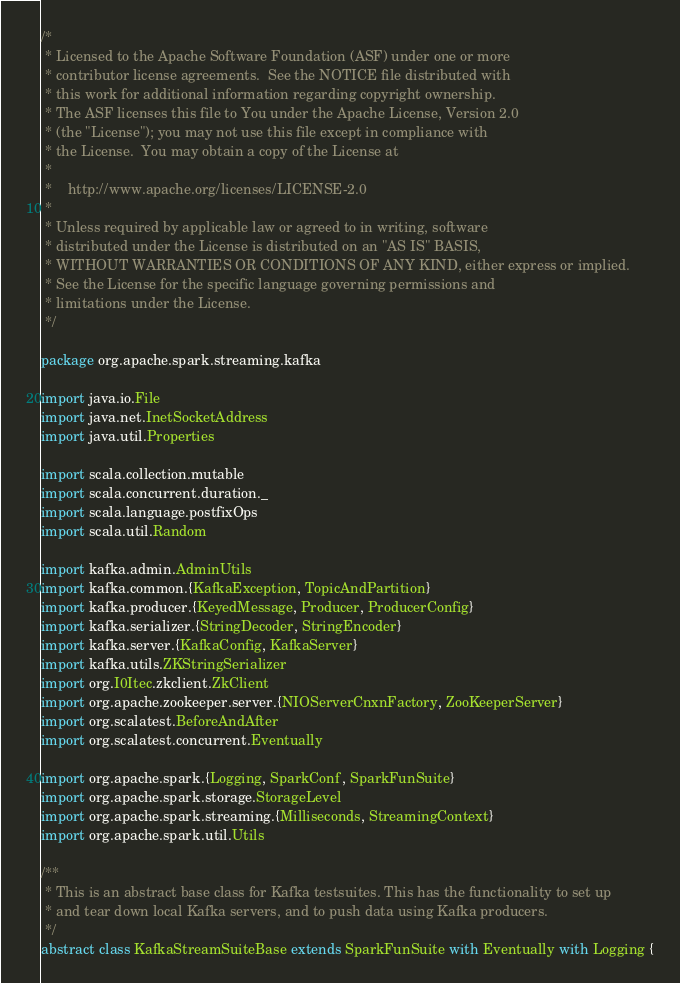<code> <loc_0><loc_0><loc_500><loc_500><_Scala_>/*
 * Licensed to the Apache Software Foundation (ASF) under one or more
 * contributor license agreements.  See the NOTICE file distributed with
 * this work for additional information regarding copyright ownership.
 * The ASF licenses this file to You under the Apache License, Version 2.0
 * (the "License"); you may not use this file except in compliance with
 * the License.  You may obtain a copy of the License at
 *
 *    http://www.apache.org/licenses/LICENSE-2.0
 *
 * Unless required by applicable law or agreed to in writing, software
 * distributed under the License is distributed on an "AS IS" BASIS,
 * WITHOUT WARRANTIES OR CONDITIONS OF ANY KIND, either express or implied.
 * See the License for the specific language governing permissions and
 * limitations under the License.
 */

package org.apache.spark.streaming.kafka

import java.io.File
import java.net.InetSocketAddress
import java.util.Properties

import scala.collection.mutable
import scala.concurrent.duration._
import scala.language.postfixOps
import scala.util.Random

import kafka.admin.AdminUtils
import kafka.common.{KafkaException, TopicAndPartition}
import kafka.producer.{KeyedMessage, Producer, ProducerConfig}
import kafka.serializer.{StringDecoder, StringEncoder}
import kafka.server.{KafkaConfig, KafkaServer}
import kafka.utils.ZKStringSerializer
import org.I0Itec.zkclient.ZkClient
import org.apache.zookeeper.server.{NIOServerCnxnFactory, ZooKeeperServer}
import org.scalatest.BeforeAndAfter
import org.scalatest.concurrent.Eventually

import org.apache.spark.{Logging, SparkConf, SparkFunSuite}
import org.apache.spark.storage.StorageLevel
import org.apache.spark.streaming.{Milliseconds, StreamingContext}
import org.apache.spark.util.Utils

/**
 * This is an abstract base class for Kafka testsuites. This has the functionality to set up
 * and tear down local Kafka servers, and to push data using Kafka producers.
 */
abstract class KafkaStreamSuiteBase extends SparkFunSuite with Eventually with Logging {
</code> 